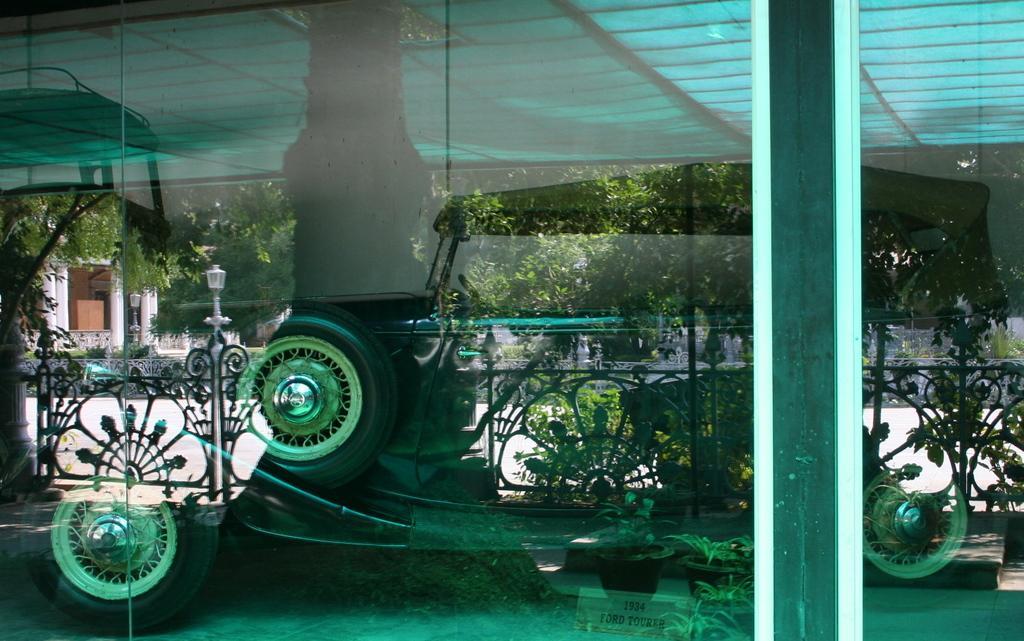Please provide a concise description of this image. This image looks like a glass window, through the glass window we can see some trees, poles, lights, plants and fence. Also, we can see a building 